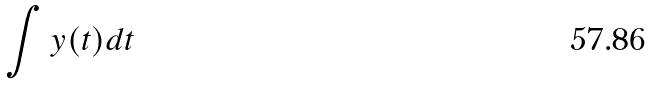Convert formula to latex. <formula><loc_0><loc_0><loc_500><loc_500>\int y ( t ) d t</formula> 